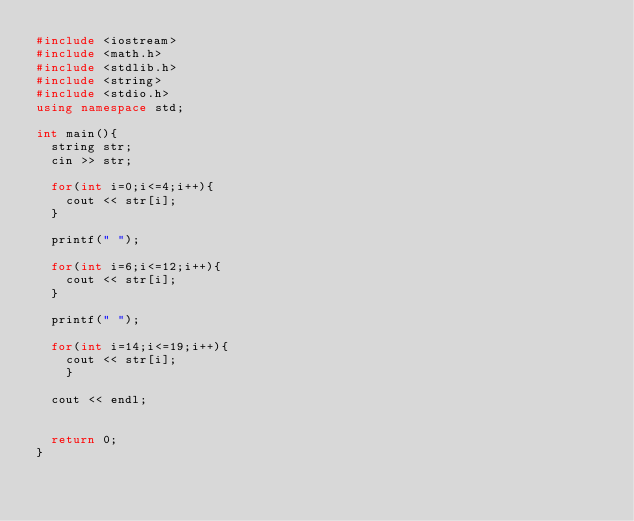Convert code to text. <code><loc_0><loc_0><loc_500><loc_500><_C++_>#include <iostream>
#include <math.h>
#include <stdlib.h>
#include <string> 
#include <stdio.h>
using namespace std;

int main(){
  string str;
  cin >> str;

  for(int i=0;i<=4;i++){
    cout << str[i];
  }
  
  printf(" ");
  
  for(int i=6;i<=12;i++){
    cout << str[i];
  }
  
  printf(" ");

  for(int i=14;i<=19;i++){
    cout << str[i];
    }

  cout << endl;


  return 0;
}
</code> 